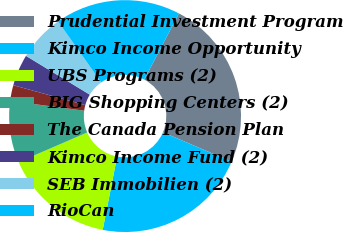<chart> <loc_0><loc_0><loc_500><loc_500><pie_chart><fcel>Prudential Investment Program<fcel>Kimco Income Opportunity<fcel>UBS Programs (2)<fcel>BIG Shopping Centers (2)<fcel>The Canada Pension Plan<fcel>Kimco Income Fund (2)<fcel>SEB Immobilien (2)<fcel>RioCan<nl><fcel>23.74%<fcel>21.65%<fcel>15.41%<fcel>8.59%<fcel>2.2%<fcel>4.4%<fcel>6.5%<fcel>17.5%<nl></chart> 